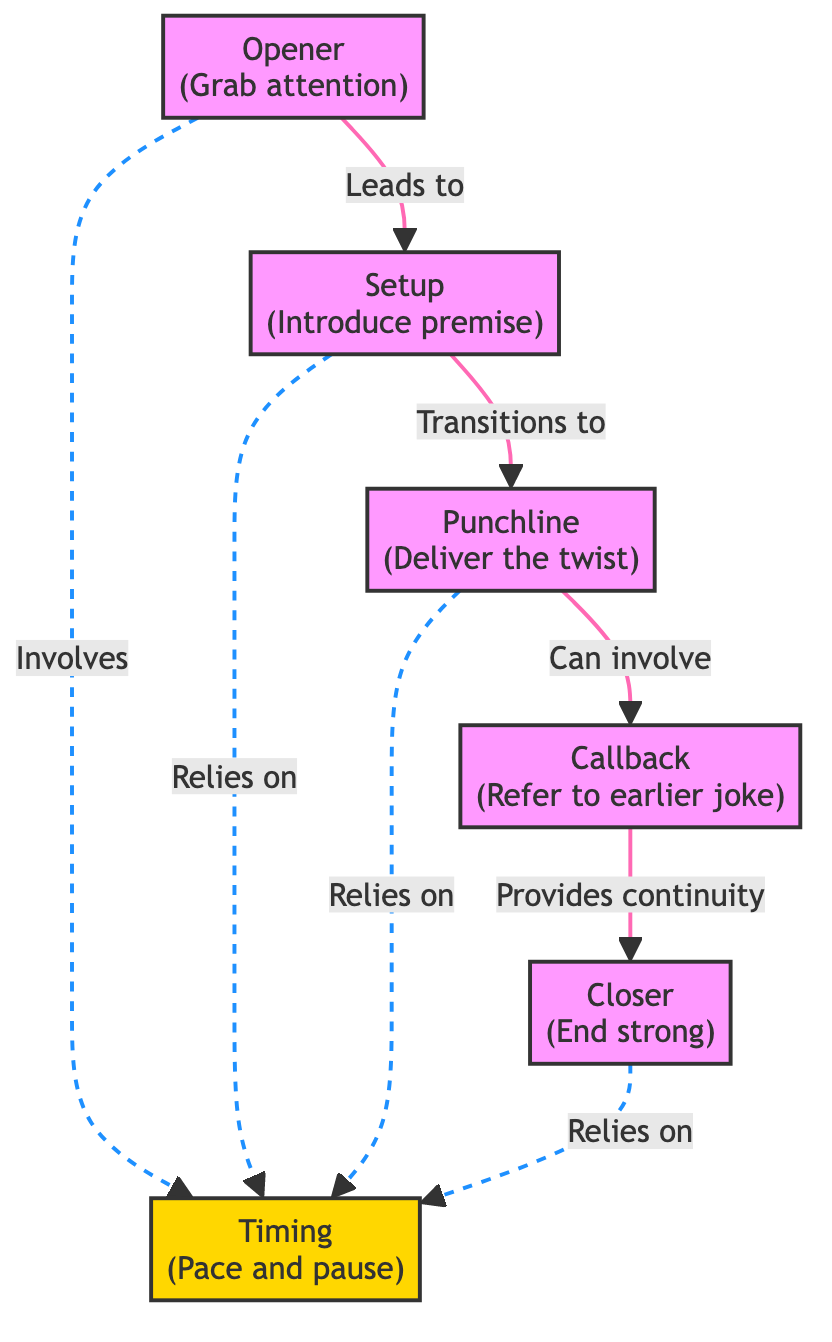What is the first step in a stand-up comedy routine? The diagram indicates that the first step is the "Opener" which is meant to grab attention.
Answer: Opener How many main components are shown in the diagram? By counting all the unique nodes in the diagram, we find there are five main components: Opener, Setup, Punchline, Callback, and Closer.
Answer: Five Which component leads to the Punchline? According to the arrows depicting the flow, the Setup leads directly to the Punchline.
Answer: Setup What role does Timing have in relation to the other components? The diagram shows that Timing is connected to all the main components, indicating it supports Opener, Setup, Punchline, and Closer in terms of pacing and pause.
Answer: Supports all components How does a Callback relate to the Closer? The diagram illustrates that a Callback provides continuity to the Closer, meaning it ties back previous jokes before concluding the routine.
Answer: Provides continuity Which component is depicted to involve Timing indirectly? The Opener, Setup, Punchline, and Closer are all shown to involve Timing through dashed lines, indicating their reliance on proper pacing and pauses.
Answer: Opener, Setup, Punchline, Closer What does the diagram suggest about the relationship between the Punchline and Callback? The diagram indicates that while the Punchline can involve a Callback, it does not necessarily have to; it illustrates a potential connection rather than a definitive one.
Answer: Can involve What is the purpose of the Closer in this structure? The Closer is described as the component that ends the routine strong, signifying it brings everything to a conclusion.
Answer: End strong What type of arrows connect the components explicitly versus implicitly? Solid arrows indicate direct connections, like the flow between Opener, Setup, Punchline, and Closer, while dashed arrows imply indirect relationships, like the influence of Timing.
Answer: Solid and dashed arrows 